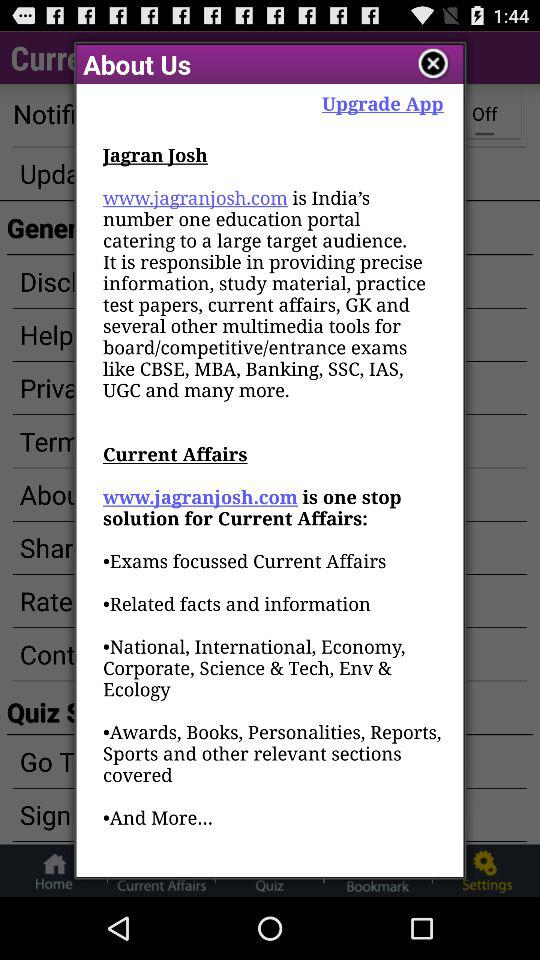What is the Current Affairs?
When the provided information is insufficient, respond with <no answer>. <no answer> 